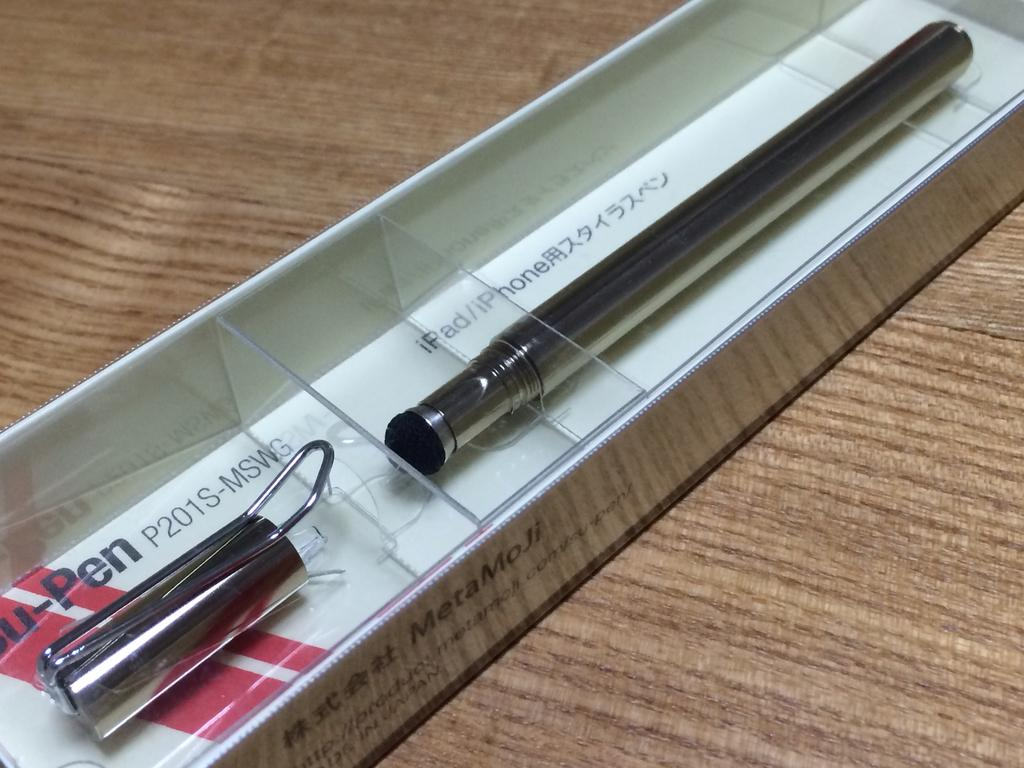What can be seen in the image? There is an object in the image. How is the object being stored or contained? The object is kept in a box. Where is the box located? The box is placed on a table. How many planes can be seen flying in the image? There are no planes visible in the image. Is there a cat present in the image? No, there is no cat present in the image. Is anyone wearing a mask in the image? There is no mention of a mask in the image. 